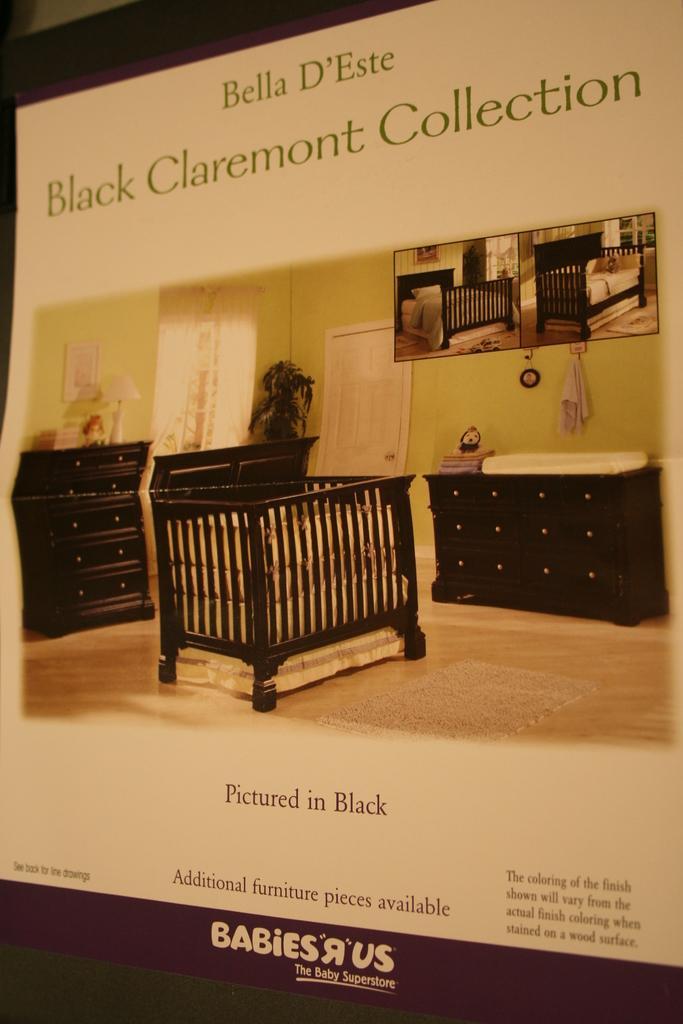How would you summarize this image in a sentence or two? In this image I can see few cupboards and I can see the lamp and few objects on the cupboards. I can see the door, plant, window, wooden object and the frame is attached to the green color wall and something is written on the image. 